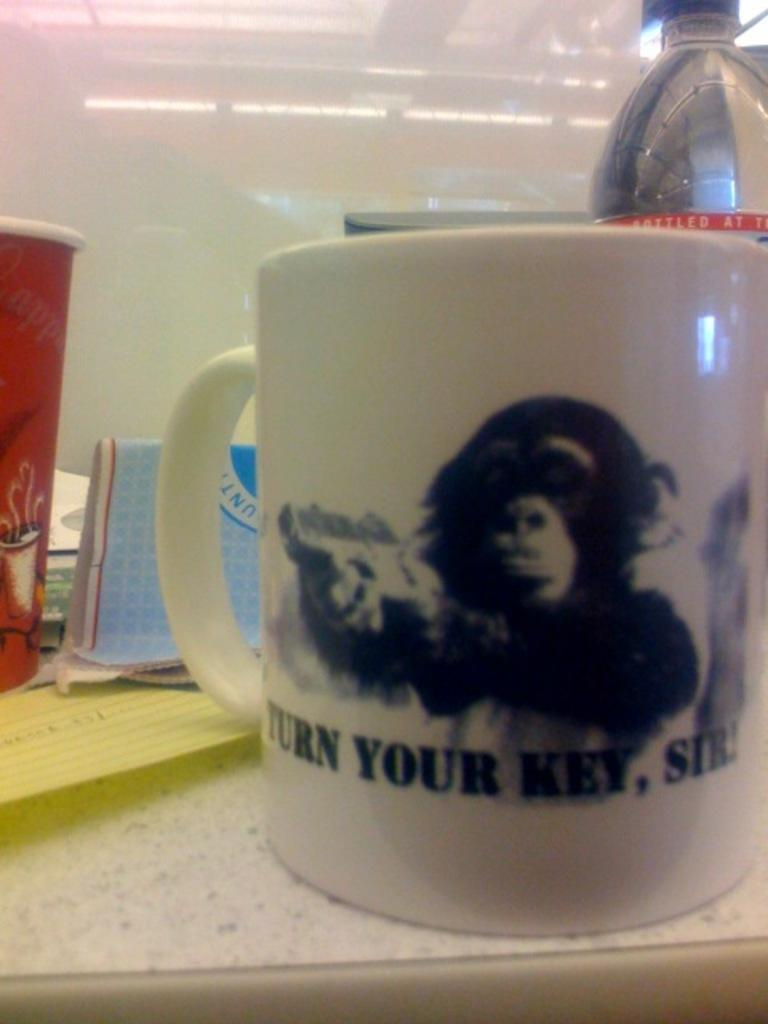<image>
Relay a brief, clear account of the picture shown. A coffe mug with a graphic of a monkey with the phrase "Turn Your Key Sir" below. 